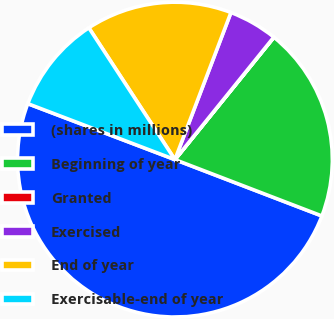<chart> <loc_0><loc_0><loc_500><loc_500><pie_chart><fcel>(shares in millions)<fcel>Beginning of year<fcel>Granted<fcel>Exercised<fcel>End of year<fcel>Exercisable-end of year<nl><fcel>49.96%<fcel>20.0%<fcel>0.02%<fcel>5.02%<fcel>15.0%<fcel>10.01%<nl></chart> 